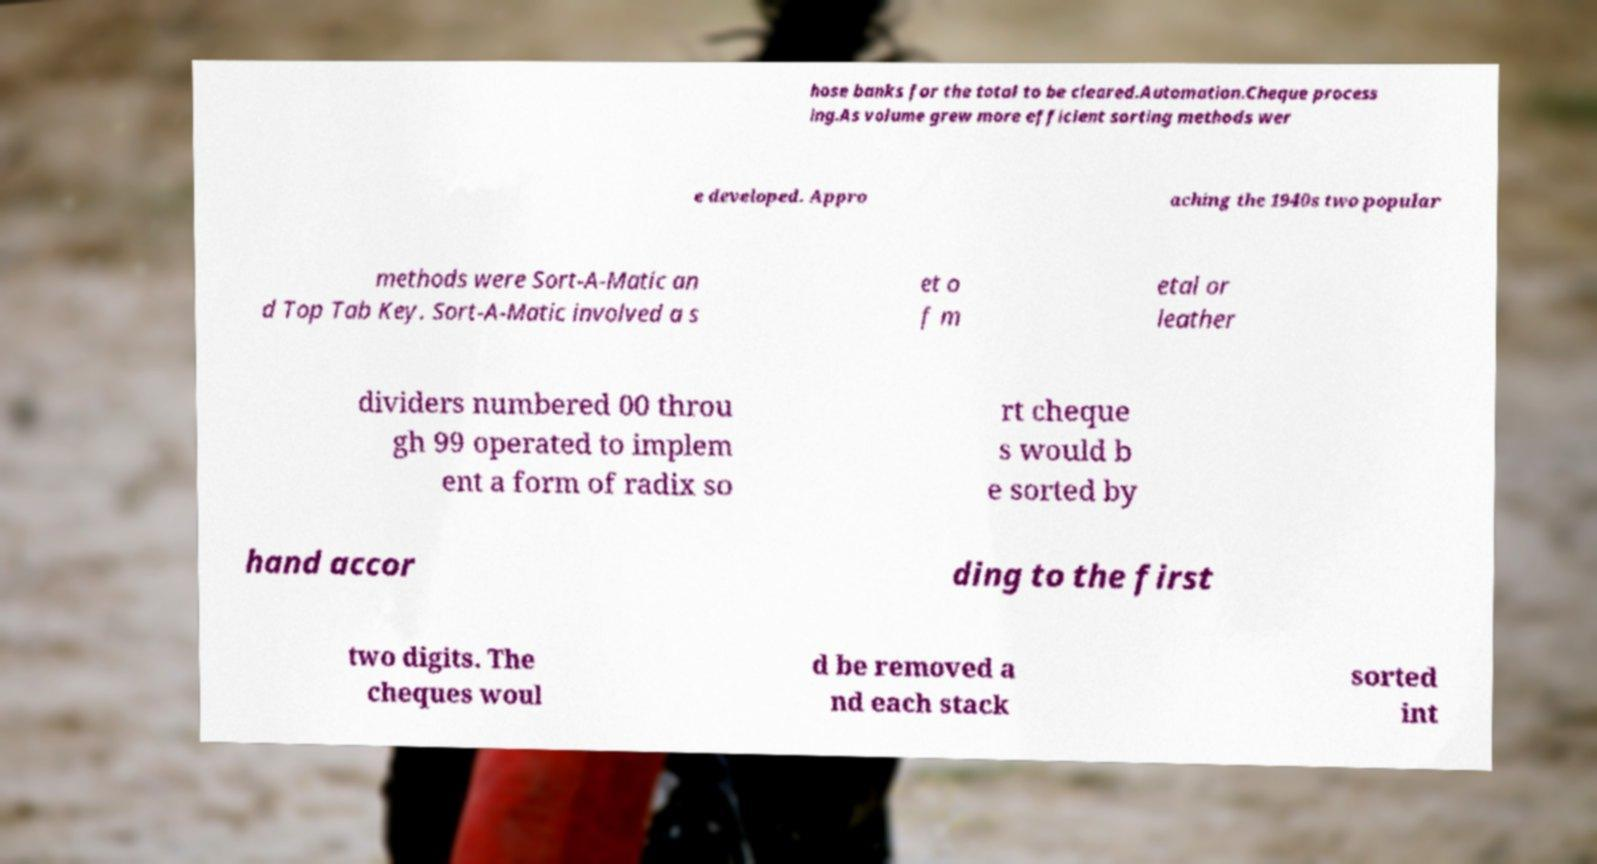What messages or text are displayed in this image? I need them in a readable, typed format. hose banks for the total to be cleared.Automation.Cheque process ing.As volume grew more efficient sorting methods wer e developed. Appro aching the 1940s two popular methods were Sort-A-Matic an d Top Tab Key. Sort-A-Matic involved a s et o f m etal or leather dividers numbered 00 throu gh 99 operated to implem ent a form of radix so rt cheque s would b e sorted by hand accor ding to the first two digits. The cheques woul d be removed a nd each stack sorted int 